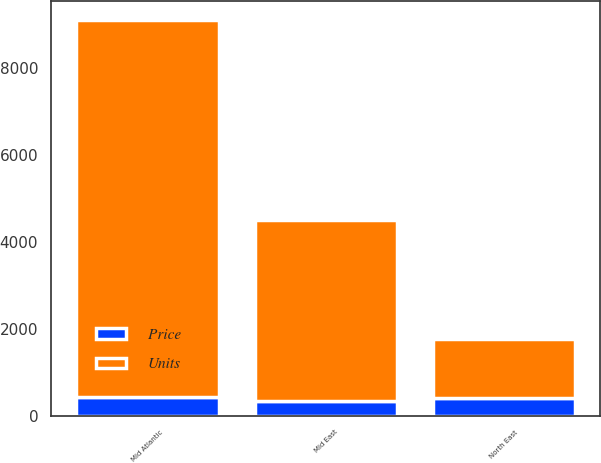<chart> <loc_0><loc_0><loc_500><loc_500><stacked_bar_chart><ecel><fcel>Mid Atlantic<fcel>North East<fcel>Mid East<nl><fcel>Units<fcel>8654<fcel>1362<fcel>4171<nl><fcel>Price<fcel>438.9<fcel>409.7<fcel>332.7<nl></chart> 